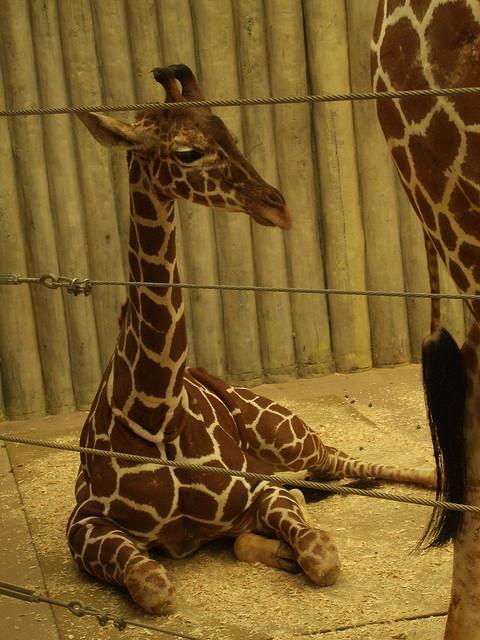How many giraffes are there?
Give a very brief answer. 2. 